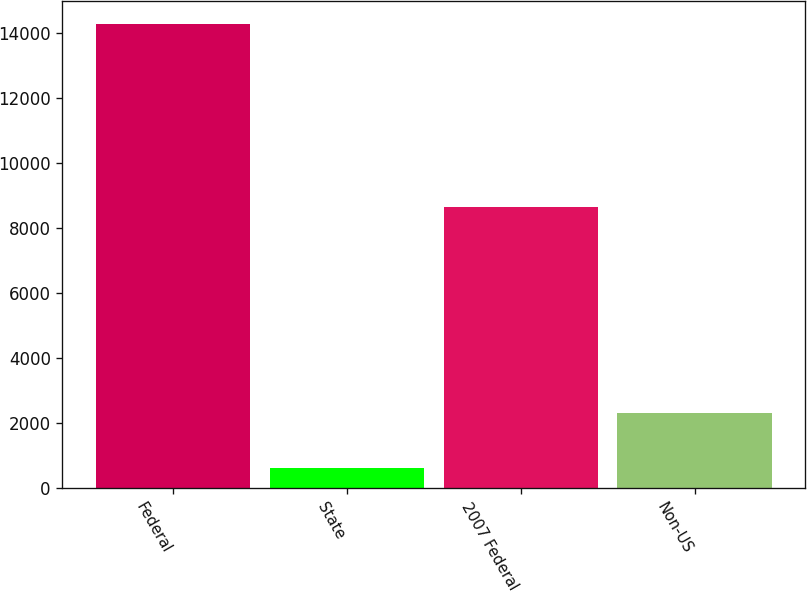Convert chart to OTSL. <chart><loc_0><loc_0><loc_500><loc_500><bar_chart><fcel>Federal<fcel>State<fcel>2007 Federal<fcel>Non-US<nl><fcel>14255<fcel>625<fcel>8634<fcel>2300<nl></chart> 